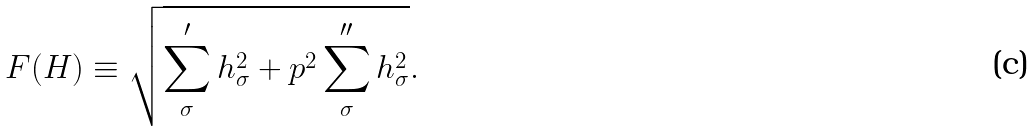Convert formula to latex. <formula><loc_0><loc_0><loc_500><loc_500>F ( H ) \equiv \sqrt { \sum _ { \sigma } ^ { \prime } h _ { \sigma } ^ { 2 } + p ^ { 2 } \sum _ { \sigma } ^ { \prime \prime } h _ { \sigma } ^ { 2 } } .</formula> 